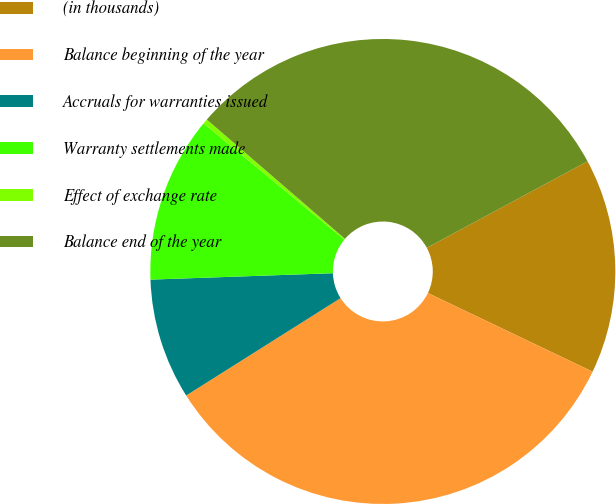Convert chart to OTSL. <chart><loc_0><loc_0><loc_500><loc_500><pie_chart><fcel>(in thousands)<fcel>Balance beginning of the year<fcel>Accruals for warranties issued<fcel>Warranty settlements made<fcel>Effect of exchange rate<fcel>Balance end of the year<nl><fcel>14.95%<fcel>33.95%<fcel>8.4%<fcel>11.54%<fcel>0.35%<fcel>30.81%<nl></chart> 